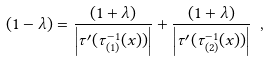Convert formula to latex. <formula><loc_0><loc_0><loc_500><loc_500>( 1 - \lambda ) = \frac { ( 1 + \lambda ) } { \left | \tau ^ { \prime } ( \tau _ { ( 1 ) } ^ { - 1 } ( x ) ) \right | } + \frac { ( 1 + \lambda ) } { \left | \tau ^ { \prime } ( \tau _ { ( 2 ) } ^ { - 1 } ( x ) ) \right | } \ ,</formula> 